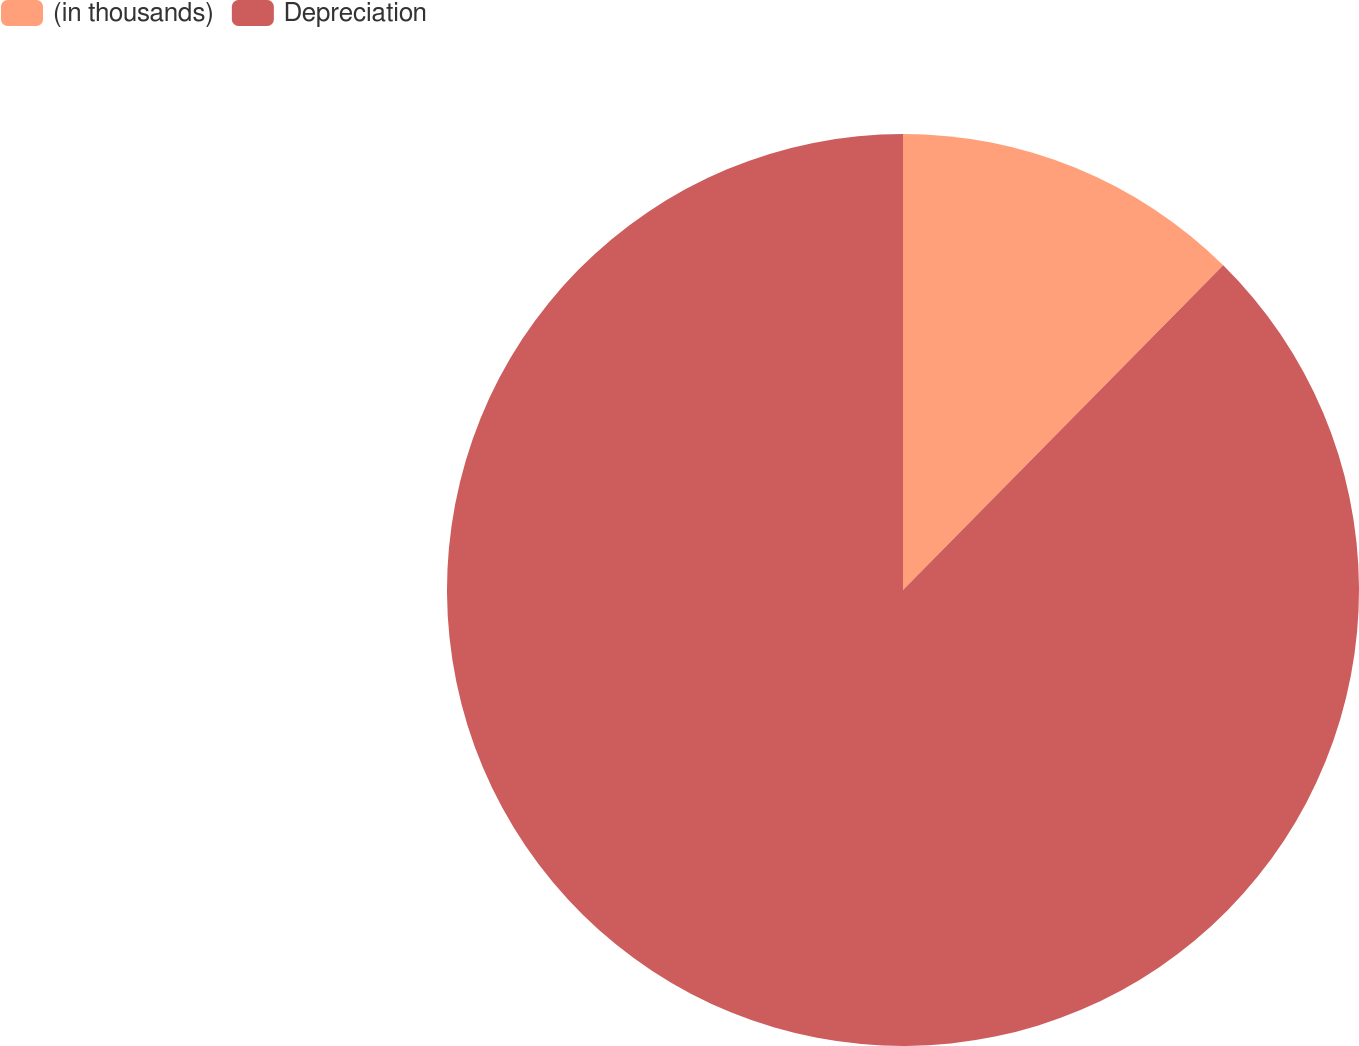Convert chart to OTSL. <chart><loc_0><loc_0><loc_500><loc_500><pie_chart><fcel>(in thousands)<fcel>Depreciation<nl><fcel>12.39%<fcel>87.61%<nl></chart> 